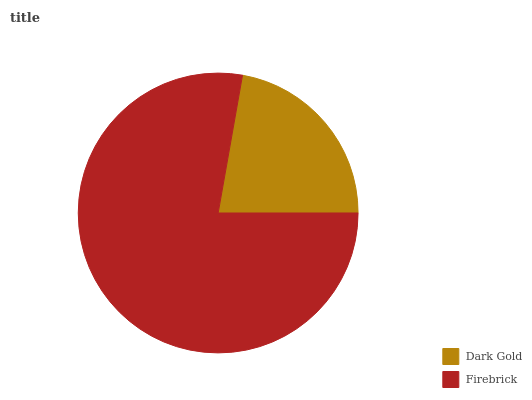Is Dark Gold the minimum?
Answer yes or no. Yes. Is Firebrick the maximum?
Answer yes or no. Yes. Is Firebrick the minimum?
Answer yes or no. No. Is Firebrick greater than Dark Gold?
Answer yes or no. Yes. Is Dark Gold less than Firebrick?
Answer yes or no. Yes. Is Dark Gold greater than Firebrick?
Answer yes or no. No. Is Firebrick less than Dark Gold?
Answer yes or no. No. Is Firebrick the high median?
Answer yes or no. Yes. Is Dark Gold the low median?
Answer yes or no. Yes. Is Dark Gold the high median?
Answer yes or no. No. Is Firebrick the low median?
Answer yes or no. No. 